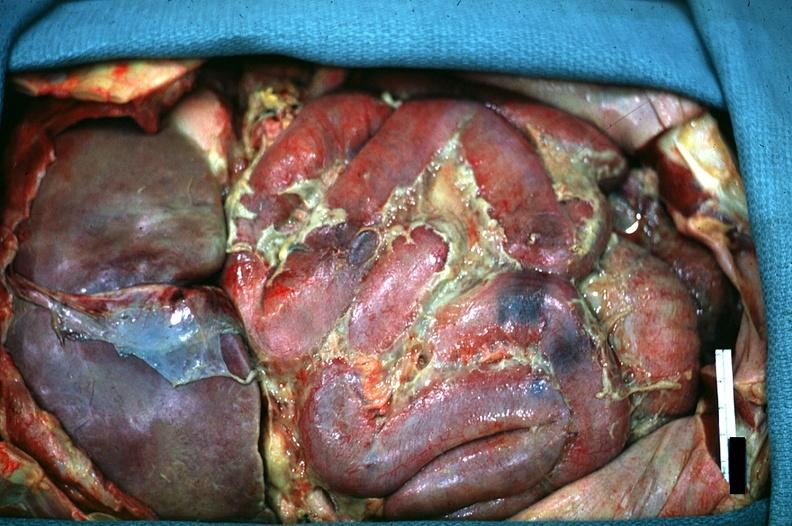where is this area in the body?
Answer the question using a single word or phrase. Abdomen 